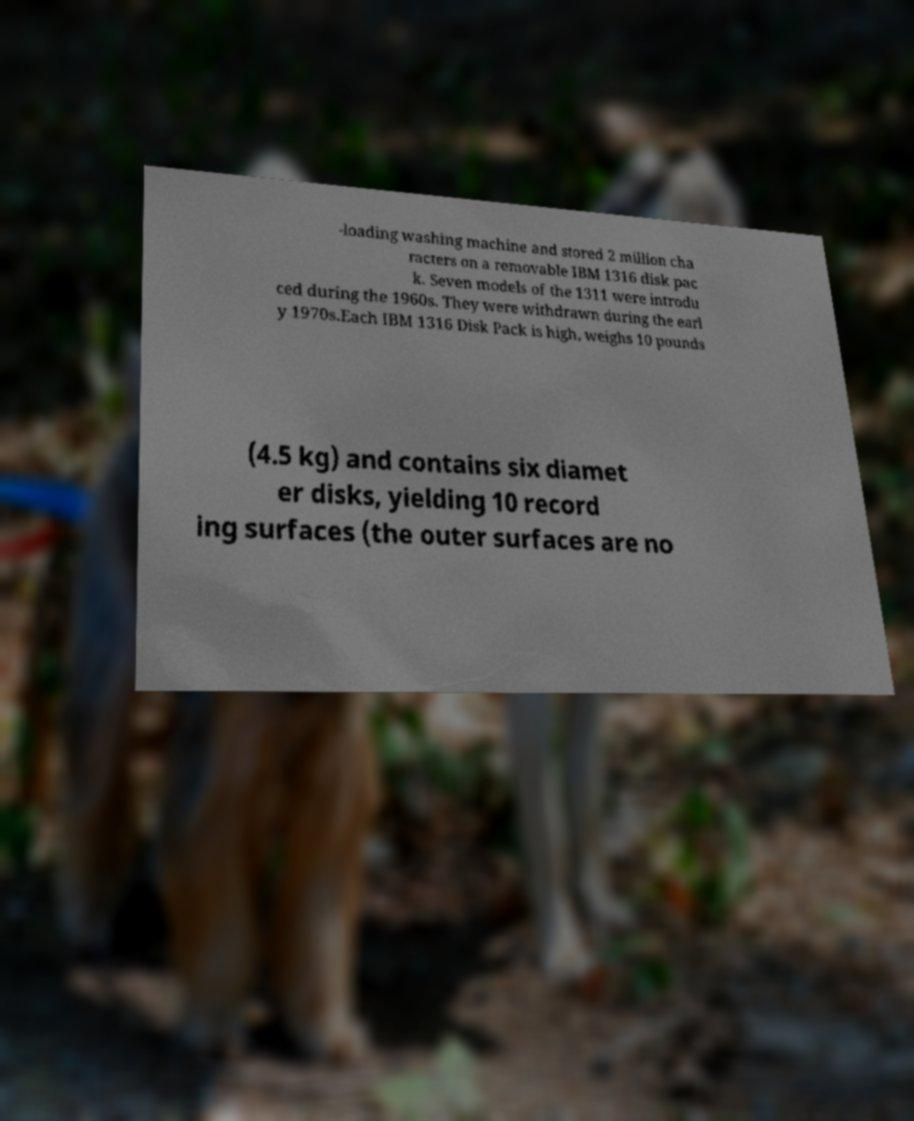Please identify and transcribe the text found in this image. -loading washing machine and stored 2 million cha racters on a removable IBM 1316 disk pac k. Seven models of the 1311 were introdu ced during the 1960s. They were withdrawn during the earl y 1970s.Each IBM 1316 Disk Pack is high, weighs 10 pounds (4.5 kg) and contains six diamet er disks, yielding 10 record ing surfaces (the outer surfaces are no 